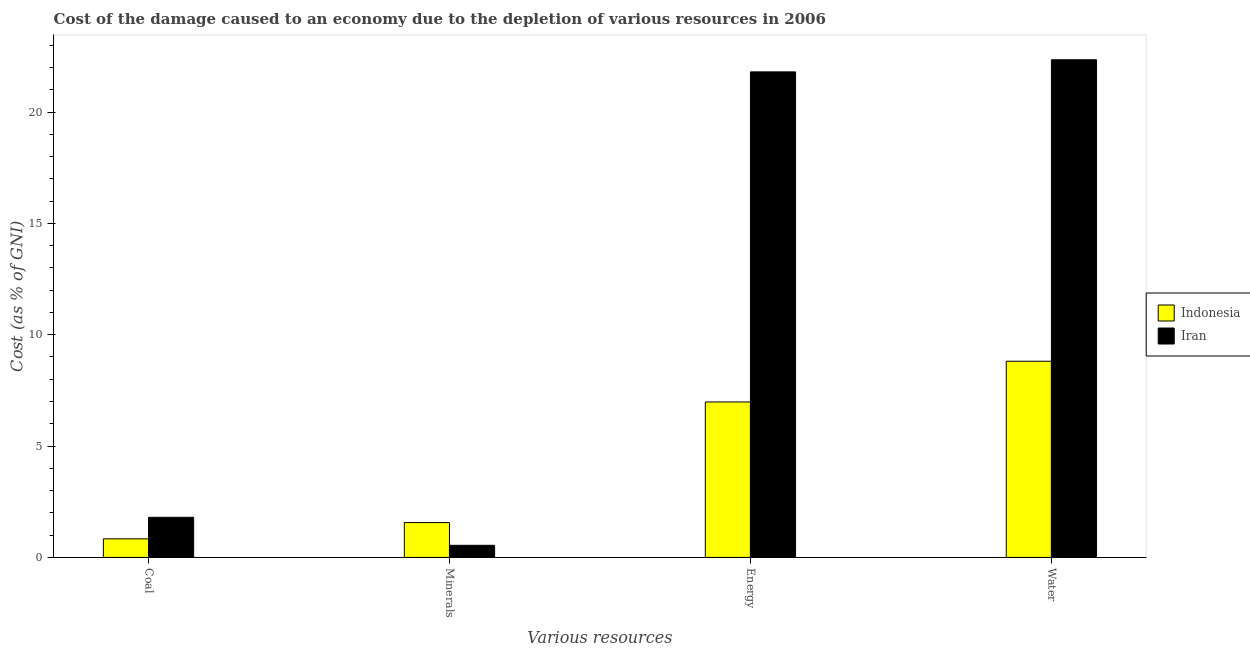How many bars are there on the 4th tick from the left?
Give a very brief answer. 2. How many bars are there on the 3rd tick from the right?
Provide a short and direct response. 2. What is the label of the 2nd group of bars from the left?
Provide a short and direct response. Minerals. What is the cost of damage due to depletion of minerals in Indonesia?
Offer a very short reply. 1.57. Across all countries, what is the maximum cost of damage due to depletion of coal?
Provide a succinct answer. 1.8. Across all countries, what is the minimum cost of damage due to depletion of energy?
Provide a short and direct response. 6.98. In which country was the cost of damage due to depletion of energy maximum?
Offer a very short reply. Iran. In which country was the cost of damage due to depletion of water minimum?
Keep it short and to the point. Indonesia. What is the total cost of damage due to depletion of energy in the graph?
Offer a terse response. 28.78. What is the difference between the cost of damage due to depletion of coal in Indonesia and that in Iran?
Provide a succinct answer. -0.97. What is the difference between the cost of damage due to depletion of water in Indonesia and the cost of damage due to depletion of energy in Iran?
Keep it short and to the point. -12.99. What is the average cost of damage due to depletion of water per country?
Your answer should be very brief. 15.58. What is the difference between the cost of damage due to depletion of minerals and cost of damage due to depletion of water in Iran?
Your response must be concise. -21.8. In how many countries, is the cost of damage due to depletion of water greater than 15 %?
Ensure brevity in your answer.  1. What is the ratio of the cost of damage due to depletion of coal in Indonesia to that in Iran?
Your answer should be compact. 0.46. Is the difference between the cost of damage due to depletion of water in Indonesia and Iran greater than the difference between the cost of damage due to depletion of minerals in Indonesia and Iran?
Make the answer very short. No. What is the difference between the highest and the second highest cost of damage due to depletion of water?
Your response must be concise. 13.54. What is the difference between the highest and the lowest cost of damage due to depletion of energy?
Provide a succinct answer. 14.82. Is it the case that in every country, the sum of the cost of damage due to depletion of coal and cost of damage due to depletion of water is greater than the sum of cost of damage due to depletion of minerals and cost of damage due to depletion of energy?
Make the answer very short. Yes. What does the 2nd bar from the right in Energy represents?
Provide a succinct answer. Indonesia. Is it the case that in every country, the sum of the cost of damage due to depletion of coal and cost of damage due to depletion of minerals is greater than the cost of damage due to depletion of energy?
Provide a succinct answer. No. Are all the bars in the graph horizontal?
Provide a succinct answer. No. Does the graph contain any zero values?
Your answer should be very brief. No. Where does the legend appear in the graph?
Offer a terse response. Center right. How many legend labels are there?
Offer a very short reply. 2. What is the title of the graph?
Your answer should be compact. Cost of the damage caused to an economy due to the depletion of various resources in 2006 . Does "Lesotho" appear as one of the legend labels in the graph?
Give a very brief answer. No. What is the label or title of the X-axis?
Your response must be concise. Various resources. What is the label or title of the Y-axis?
Give a very brief answer. Cost (as % of GNI). What is the Cost (as % of GNI) of Indonesia in Coal?
Provide a short and direct response. 0.83. What is the Cost (as % of GNI) in Iran in Coal?
Make the answer very short. 1.8. What is the Cost (as % of GNI) in Indonesia in Minerals?
Your answer should be compact. 1.57. What is the Cost (as % of GNI) of Iran in Minerals?
Keep it short and to the point. 0.54. What is the Cost (as % of GNI) of Indonesia in Energy?
Offer a very short reply. 6.98. What is the Cost (as % of GNI) in Iran in Energy?
Make the answer very short. 21.8. What is the Cost (as % of GNI) in Indonesia in Water?
Provide a succinct answer. 8.81. What is the Cost (as % of GNI) in Iran in Water?
Make the answer very short. 22.35. Across all Various resources, what is the maximum Cost (as % of GNI) in Indonesia?
Offer a terse response. 8.81. Across all Various resources, what is the maximum Cost (as % of GNI) in Iran?
Ensure brevity in your answer.  22.35. Across all Various resources, what is the minimum Cost (as % of GNI) in Indonesia?
Your response must be concise. 0.83. Across all Various resources, what is the minimum Cost (as % of GNI) in Iran?
Offer a terse response. 0.54. What is the total Cost (as % of GNI) of Indonesia in the graph?
Your answer should be compact. 18.19. What is the total Cost (as % of GNI) of Iran in the graph?
Your response must be concise. 46.49. What is the difference between the Cost (as % of GNI) of Indonesia in Coal and that in Minerals?
Ensure brevity in your answer.  -0.73. What is the difference between the Cost (as % of GNI) in Iran in Coal and that in Minerals?
Make the answer very short. 1.26. What is the difference between the Cost (as % of GNI) of Indonesia in Coal and that in Energy?
Give a very brief answer. -6.15. What is the difference between the Cost (as % of GNI) of Iran in Coal and that in Energy?
Your response must be concise. -20. What is the difference between the Cost (as % of GNI) in Indonesia in Coal and that in Water?
Ensure brevity in your answer.  -7.97. What is the difference between the Cost (as % of GNI) in Iran in Coal and that in Water?
Offer a terse response. -20.55. What is the difference between the Cost (as % of GNI) of Indonesia in Minerals and that in Energy?
Provide a succinct answer. -5.42. What is the difference between the Cost (as % of GNI) in Iran in Minerals and that in Energy?
Provide a succinct answer. -21.26. What is the difference between the Cost (as % of GNI) in Indonesia in Minerals and that in Water?
Make the answer very short. -7.24. What is the difference between the Cost (as % of GNI) of Iran in Minerals and that in Water?
Your response must be concise. -21.8. What is the difference between the Cost (as % of GNI) in Indonesia in Energy and that in Water?
Make the answer very short. -1.83. What is the difference between the Cost (as % of GNI) of Iran in Energy and that in Water?
Your answer should be compact. -0.54. What is the difference between the Cost (as % of GNI) of Indonesia in Coal and the Cost (as % of GNI) of Iran in Minerals?
Ensure brevity in your answer.  0.29. What is the difference between the Cost (as % of GNI) of Indonesia in Coal and the Cost (as % of GNI) of Iran in Energy?
Ensure brevity in your answer.  -20.97. What is the difference between the Cost (as % of GNI) of Indonesia in Coal and the Cost (as % of GNI) of Iran in Water?
Make the answer very short. -21.51. What is the difference between the Cost (as % of GNI) of Indonesia in Minerals and the Cost (as % of GNI) of Iran in Energy?
Provide a succinct answer. -20.24. What is the difference between the Cost (as % of GNI) in Indonesia in Minerals and the Cost (as % of GNI) in Iran in Water?
Make the answer very short. -20.78. What is the difference between the Cost (as % of GNI) of Indonesia in Energy and the Cost (as % of GNI) of Iran in Water?
Provide a succinct answer. -15.37. What is the average Cost (as % of GNI) in Indonesia per Various resources?
Your answer should be very brief. 4.55. What is the average Cost (as % of GNI) in Iran per Various resources?
Your response must be concise. 11.62. What is the difference between the Cost (as % of GNI) in Indonesia and Cost (as % of GNI) in Iran in Coal?
Offer a very short reply. -0.97. What is the difference between the Cost (as % of GNI) in Indonesia and Cost (as % of GNI) in Iran in Minerals?
Your answer should be compact. 1.02. What is the difference between the Cost (as % of GNI) of Indonesia and Cost (as % of GNI) of Iran in Energy?
Ensure brevity in your answer.  -14.82. What is the difference between the Cost (as % of GNI) in Indonesia and Cost (as % of GNI) in Iran in Water?
Your response must be concise. -13.54. What is the ratio of the Cost (as % of GNI) of Indonesia in Coal to that in Minerals?
Offer a terse response. 0.53. What is the ratio of the Cost (as % of GNI) of Iran in Coal to that in Minerals?
Your answer should be very brief. 3.31. What is the ratio of the Cost (as % of GNI) in Indonesia in Coal to that in Energy?
Offer a very short reply. 0.12. What is the ratio of the Cost (as % of GNI) in Iran in Coal to that in Energy?
Ensure brevity in your answer.  0.08. What is the ratio of the Cost (as % of GNI) of Indonesia in Coal to that in Water?
Provide a succinct answer. 0.09. What is the ratio of the Cost (as % of GNI) of Iran in Coal to that in Water?
Your answer should be very brief. 0.08. What is the ratio of the Cost (as % of GNI) in Indonesia in Minerals to that in Energy?
Your response must be concise. 0.22. What is the ratio of the Cost (as % of GNI) in Iran in Minerals to that in Energy?
Your response must be concise. 0.03. What is the ratio of the Cost (as % of GNI) of Indonesia in Minerals to that in Water?
Keep it short and to the point. 0.18. What is the ratio of the Cost (as % of GNI) of Iran in Minerals to that in Water?
Keep it short and to the point. 0.02. What is the ratio of the Cost (as % of GNI) in Indonesia in Energy to that in Water?
Make the answer very short. 0.79. What is the ratio of the Cost (as % of GNI) in Iran in Energy to that in Water?
Ensure brevity in your answer.  0.98. What is the difference between the highest and the second highest Cost (as % of GNI) of Indonesia?
Make the answer very short. 1.83. What is the difference between the highest and the second highest Cost (as % of GNI) of Iran?
Offer a terse response. 0.54. What is the difference between the highest and the lowest Cost (as % of GNI) of Indonesia?
Offer a very short reply. 7.97. What is the difference between the highest and the lowest Cost (as % of GNI) of Iran?
Offer a very short reply. 21.8. 